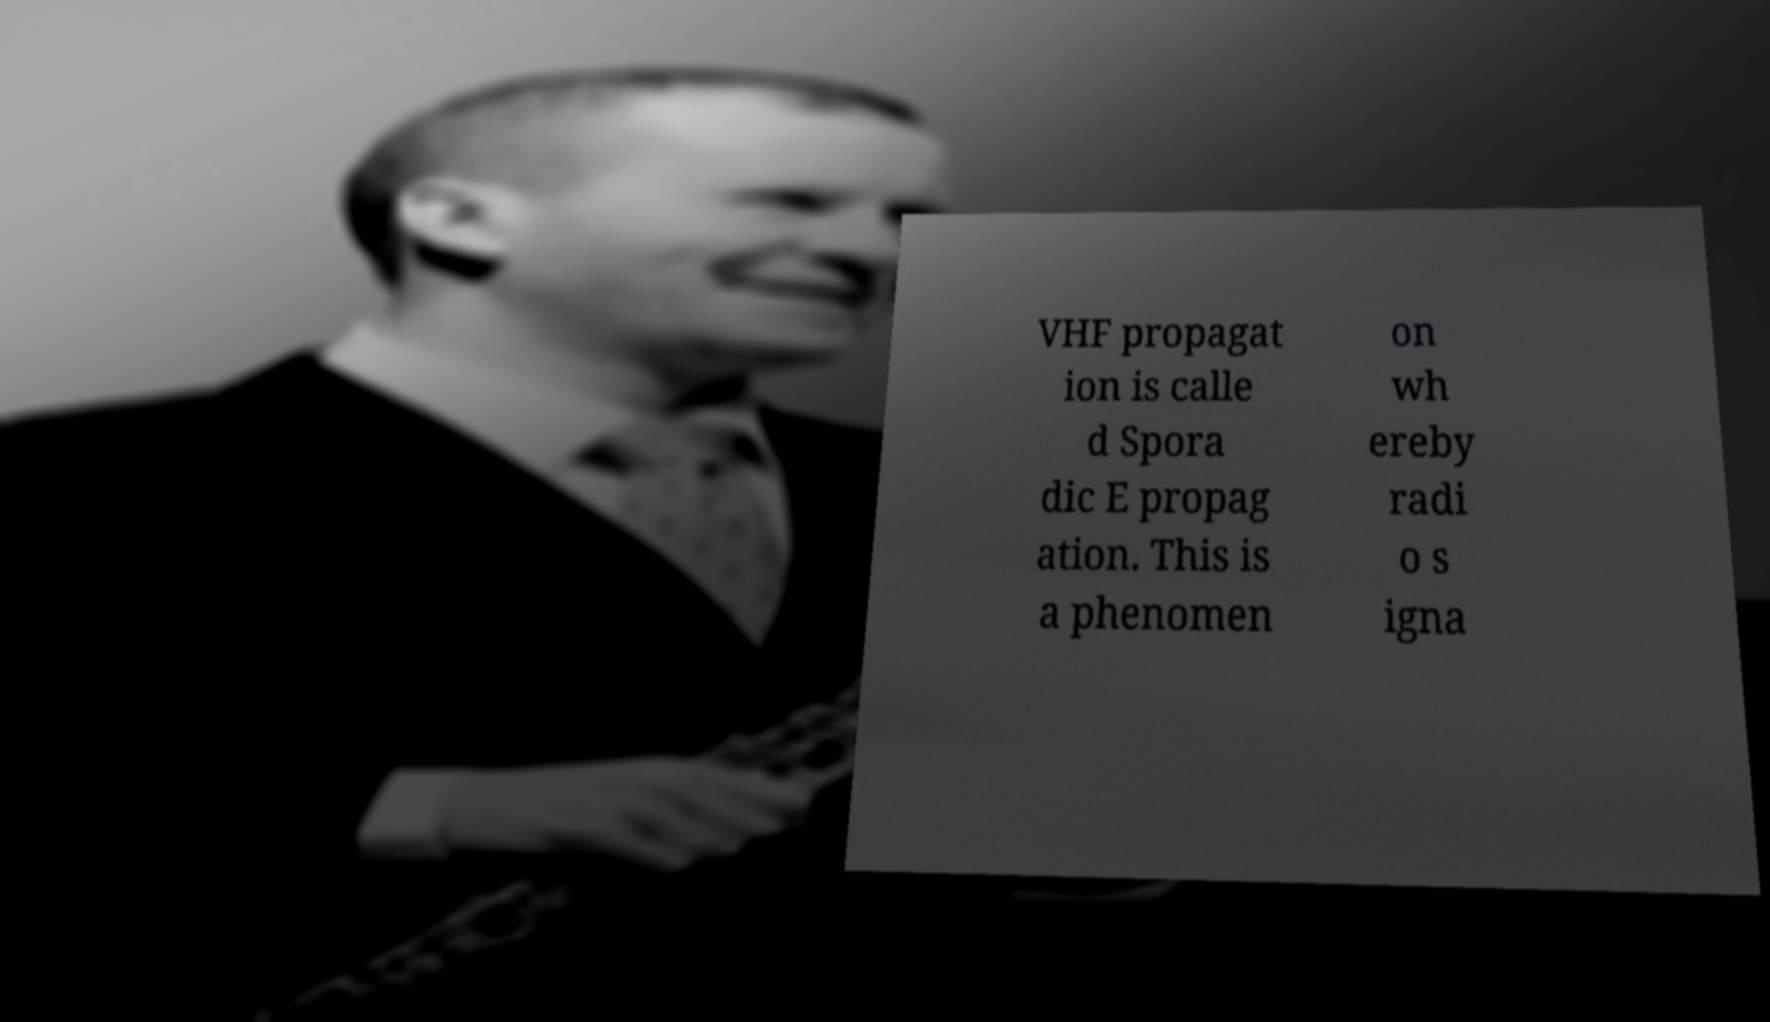There's text embedded in this image that I need extracted. Can you transcribe it verbatim? VHF propagat ion is calle d Spora dic E propag ation. This is a phenomen on wh ereby radi o s igna 